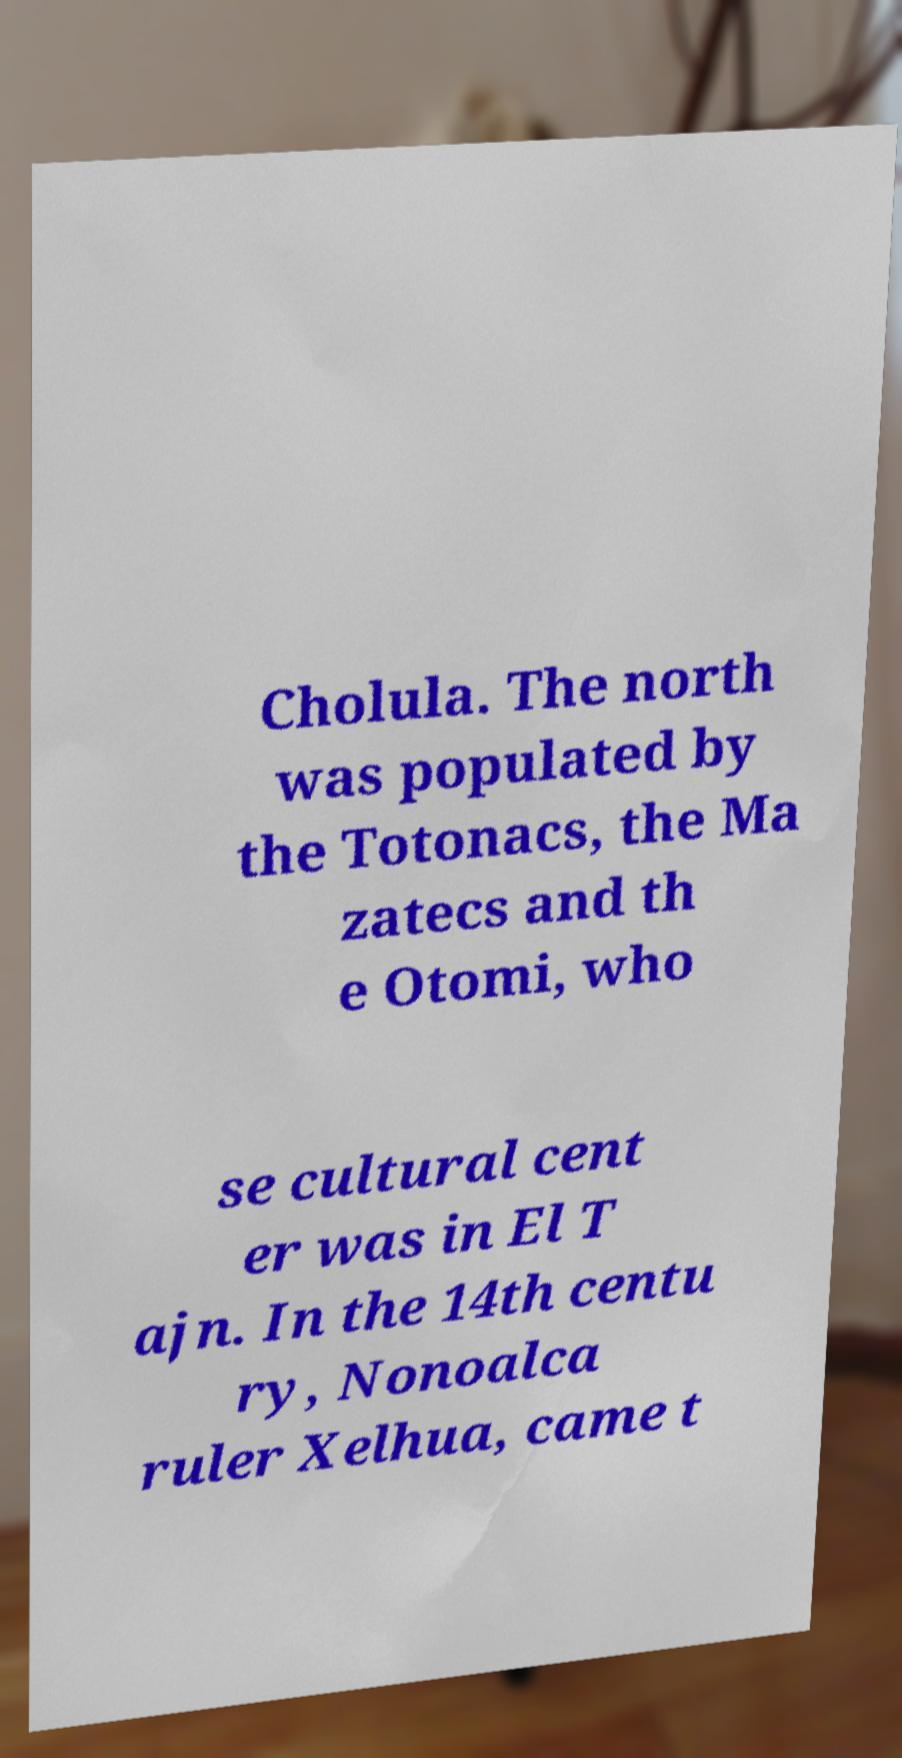For documentation purposes, I need the text within this image transcribed. Could you provide that? Cholula. The north was populated by the Totonacs, the Ma zatecs and th e Otomi, who se cultural cent er was in El T ajn. In the 14th centu ry, Nonoalca ruler Xelhua, came t 